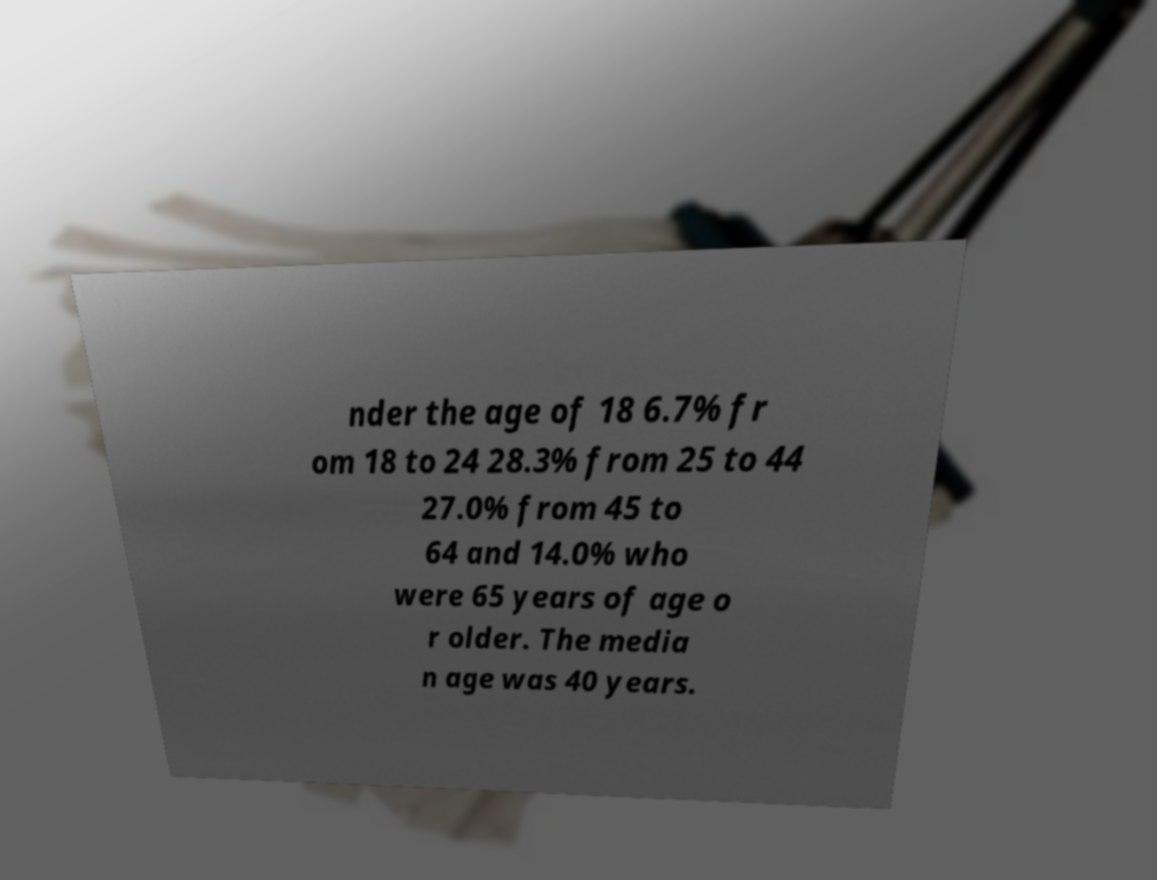I need the written content from this picture converted into text. Can you do that? nder the age of 18 6.7% fr om 18 to 24 28.3% from 25 to 44 27.0% from 45 to 64 and 14.0% who were 65 years of age o r older. The media n age was 40 years. 